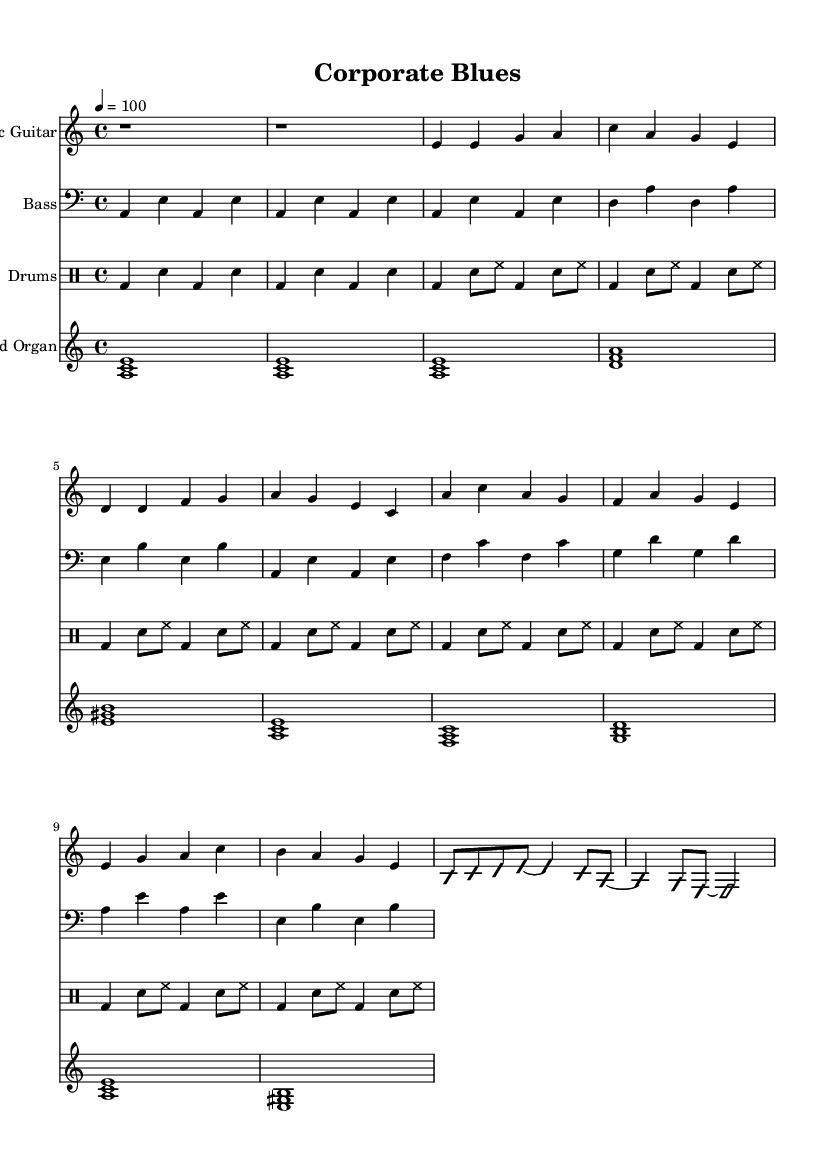What is the key signature of this music? The key signature is indicated at the beginning of the sheet music, which shows an "A minor" key. This means there are no sharps or flats in the key signature.
Answer: A minor What is the time signature of this piece? The time signature is also found at the beginning of the sheet music. It is shown as "4/4", which indicates there are four beats in a measure and the quarter note receives one beat.
Answer: 4/4 What is the tempo marking for the song? The tempo marking, given as "4 = 100", indicates that the piece should be played at a speed of 100 beats per minute. This is typically referred to as "moderate."
Answer: 100 How many measures are there in the verse section? To determine the number of measures in the verse section, we can look at the "Verse 1" section of the electric guitar part, which has 4 measures, followed by the same in the bass part.
Answer: 4 What is the structure of the song regarding different sections? The structure can be inferred from the labeled sections: it begins with an "Intro", followed by "Verse 1", then transitions to "Chorus", and includes a "Guitar Solo". This indicates a common Electric Blues format.
Answer: Intro, Verse 1, Chorus, Guitar Solo What instruments are included in this electric blues composition? The sheet music lists the following instruments: Electric Guitar, Bass, Drums, and Hammond Organ. Each is indicated at the start of its respective staff.
Answer: Electric Guitar, Bass, Drums, Hammond Organ What characteristic of electric blues is evident in the solo section? The "Guitar Solo", marked as "improvisationOn," indicates an improvisational style typical of Electric Blues, where the guitarist uses freedom of expression over the given chord progressions.
Answer: Improvisation 